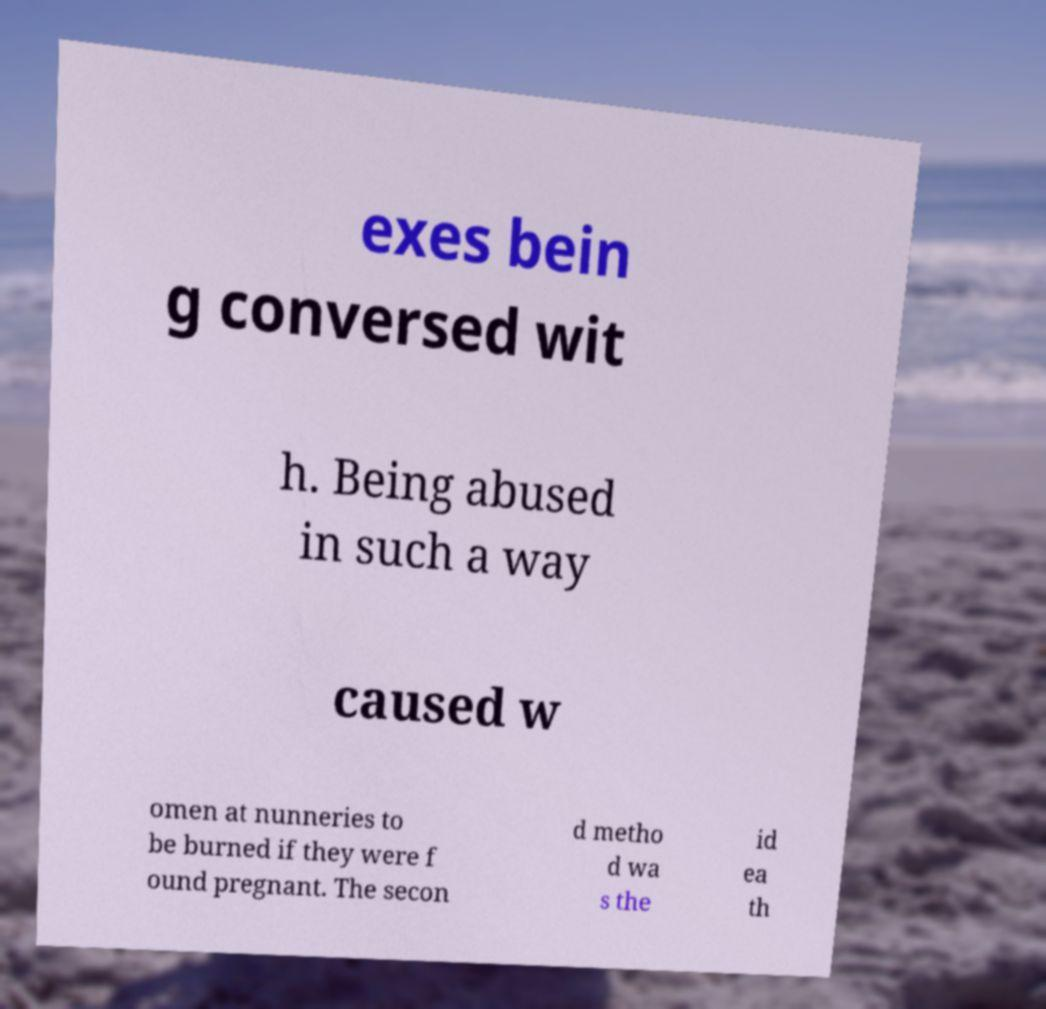For documentation purposes, I need the text within this image transcribed. Could you provide that? exes bein g conversed wit h. Being abused in such a way caused w omen at nunneries to be burned if they were f ound pregnant. The secon d metho d wa s the id ea th 